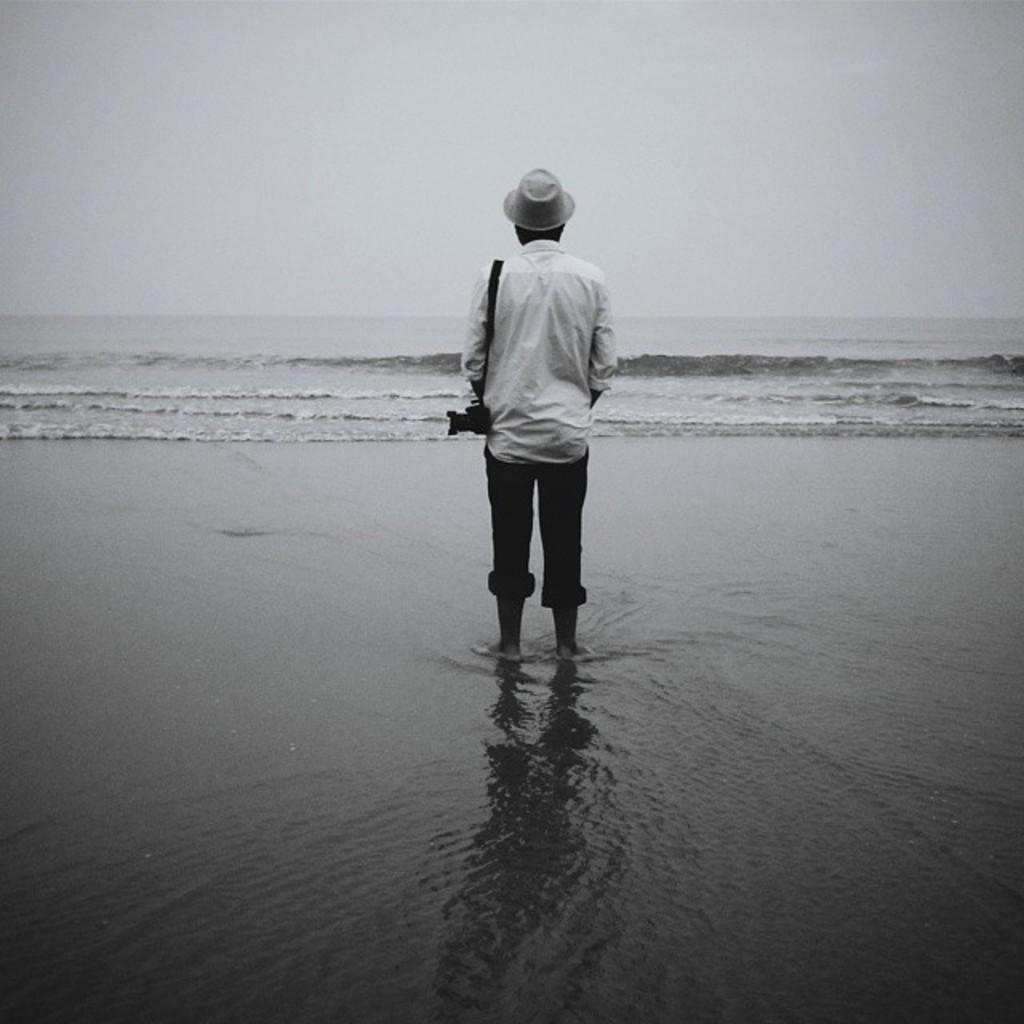What is the main subject of the image? There is a person in the image. What is the person wearing on their head? The person is wearing a cap. What is the person holding in the image? The person is carrying a camera. What is the person's posture in the image? The person is standing. What can be seen in the background of the image? Water and the sky are visible in the background of the image. What type of root can be seen growing from the person's camera in the image? There is no root growing from the person's camera in the image. Is there a lock visible on the person's cap in the image? There is no lock visible on the person's cap in the image. 